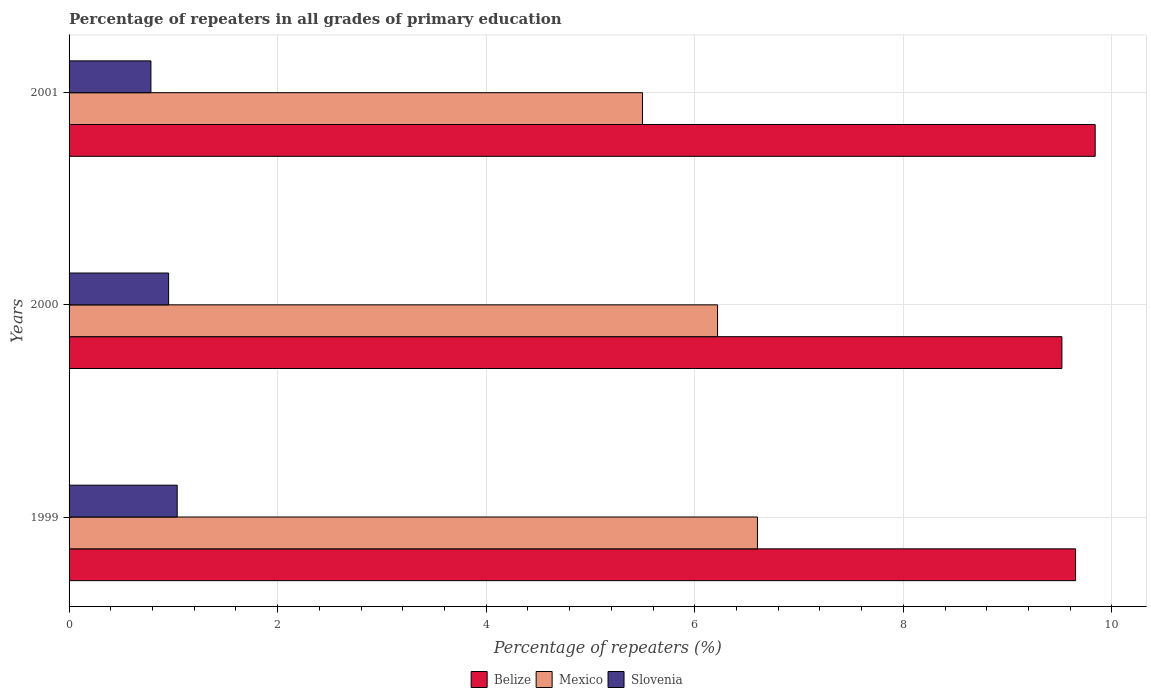How many groups of bars are there?
Give a very brief answer. 3. What is the percentage of repeaters in Mexico in 2000?
Offer a terse response. 6.22. Across all years, what is the maximum percentage of repeaters in Mexico?
Provide a succinct answer. 6.6. Across all years, what is the minimum percentage of repeaters in Belize?
Give a very brief answer. 9.52. In which year was the percentage of repeaters in Slovenia maximum?
Provide a short and direct response. 1999. In which year was the percentage of repeaters in Belize minimum?
Keep it short and to the point. 2000. What is the total percentage of repeaters in Belize in the graph?
Make the answer very short. 29.01. What is the difference between the percentage of repeaters in Mexico in 2000 and that in 2001?
Your answer should be compact. 0.72. What is the difference between the percentage of repeaters in Belize in 2000 and the percentage of repeaters in Mexico in 2001?
Offer a terse response. 4.02. What is the average percentage of repeaters in Slovenia per year?
Ensure brevity in your answer.  0.93. In the year 1999, what is the difference between the percentage of repeaters in Belize and percentage of repeaters in Mexico?
Give a very brief answer. 3.05. In how many years, is the percentage of repeaters in Slovenia greater than 6 %?
Give a very brief answer. 0. What is the ratio of the percentage of repeaters in Belize in 2000 to that in 2001?
Ensure brevity in your answer.  0.97. What is the difference between the highest and the second highest percentage of repeaters in Slovenia?
Ensure brevity in your answer.  0.08. What is the difference between the highest and the lowest percentage of repeaters in Mexico?
Make the answer very short. 1.1. Is the sum of the percentage of repeaters in Slovenia in 2000 and 2001 greater than the maximum percentage of repeaters in Belize across all years?
Keep it short and to the point. No. What does the 1st bar from the top in 2000 represents?
Provide a succinct answer. Slovenia. What does the 2nd bar from the bottom in 1999 represents?
Your response must be concise. Mexico. How many years are there in the graph?
Provide a succinct answer. 3. What is the difference between two consecutive major ticks on the X-axis?
Make the answer very short. 2. Are the values on the major ticks of X-axis written in scientific E-notation?
Provide a short and direct response. No. Does the graph contain grids?
Make the answer very short. Yes. How are the legend labels stacked?
Your response must be concise. Horizontal. What is the title of the graph?
Your answer should be very brief. Percentage of repeaters in all grades of primary education. Does "Ireland" appear as one of the legend labels in the graph?
Your response must be concise. No. What is the label or title of the X-axis?
Your answer should be very brief. Percentage of repeaters (%). What is the label or title of the Y-axis?
Offer a very short reply. Years. What is the Percentage of repeaters (%) of Belize in 1999?
Offer a very short reply. 9.65. What is the Percentage of repeaters (%) in Mexico in 1999?
Provide a short and direct response. 6.6. What is the Percentage of repeaters (%) of Slovenia in 1999?
Your answer should be compact. 1.04. What is the Percentage of repeaters (%) of Belize in 2000?
Make the answer very short. 9.52. What is the Percentage of repeaters (%) of Mexico in 2000?
Offer a very short reply. 6.22. What is the Percentage of repeaters (%) of Slovenia in 2000?
Provide a short and direct response. 0.95. What is the Percentage of repeaters (%) of Belize in 2001?
Give a very brief answer. 9.84. What is the Percentage of repeaters (%) of Mexico in 2001?
Make the answer very short. 5.5. What is the Percentage of repeaters (%) of Slovenia in 2001?
Give a very brief answer. 0.78. Across all years, what is the maximum Percentage of repeaters (%) in Belize?
Keep it short and to the point. 9.84. Across all years, what is the maximum Percentage of repeaters (%) in Mexico?
Your response must be concise. 6.6. Across all years, what is the maximum Percentage of repeaters (%) in Slovenia?
Give a very brief answer. 1.04. Across all years, what is the minimum Percentage of repeaters (%) in Belize?
Offer a very short reply. 9.52. Across all years, what is the minimum Percentage of repeaters (%) of Mexico?
Keep it short and to the point. 5.5. Across all years, what is the minimum Percentage of repeaters (%) in Slovenia?
Ensure brevity in your answer.  0.78. What is the total Percentage of repeaters (%) in Belize in the graph?
Offer a terse response. 29.01. What is the total Percentage of repeaters (%) of Mexico in the graph?
Your answer should be compact. 18.32. What is the total Percentage of repeaters (%) in Slovenia in the graph?
Your answer should be very brief. 2.78. What is the difference between the Percentage of repeaters (%) of Belize in 1999 and that in 2000?
Provide a short and direct response. 0.13. What is the difference between the Percentage of repeaters (%) in Mexico in 1999 and that in 2000?
Offer a very short reply. 0.38. What is the difference between the Percentage of repeaters (%) in Slovenia in 1999 and that in 2000?
Offer a terse response. 0.08. What is the difference between the Percentage of repeaters (%) of Belize in 1999 and that in 2001?
Keep it short and to the point. -0.19. What is the difference between the Percentage of repeaters (%) in Mexico in 1999 and that in 2001?
Offer a very short reply. 1.1. What is the difference between the Percentage of repeaters (%) in Slovenia in 1999 and that in 2001?
Give a very brief answer. 0.25. What is the difference between the Percentage of repeaters (%) in Belize in 2000 and that in 2001?
Your response must be concise. -0.32. What is the difference between the Percentage of repeaters (%) of Mexico in 2000 and that in 2001?
Offer a very short reply. 0.72. What is the difference between the Percentage of repeaters (%) of Slovenia in 2000 and that in 2001?
Your answer should be compact. 0.17. What is the difference between the Percentage of repeaters (%) of Belize in 1999 and the Percentage of repeaters (%) of Mexico in 2000?
Keep it short and to the point. 3.43. What is the difference between the Percentage of repeaters (%) of Belize in 1999 and the Percentage of repeaters (%) of Slovenia in 2000?
Provide a succinct answer. 8.7. What is the difference between the Percentage of repeaters (%) in Mexico in 1999 and the Percentage of repeaters (%) in Slovenia in 2000?
Provide a succinct answer. 5.65. What is the difference between the Percentage of repeaters (%) of Belize in 1999 and the Percentage of repeaters (%) of Mexico in 2001?
Make the answer very short. 4.15. What is the difference between the Percentage of repeaters (%) in Belize in 1999 and the Percentage of repeaters (%) in Slovenia in 2001?
Provide a succinct answer. 8.87. What is the difference between the Percentage of repeaters (%) of Mexico in 1999 and the Percentage of repeaters (%) of Slovenia in 2001?
Your answer should be compact. 5.82. What is the difference between the Percentage of repeaters (%) of Belize in 2000 and the Percentage of repeaters (%) of Mexico in 2001?
Your answer should be compact. 4.02. What is the difference between the Percentage of repeaters (%) in Belize in 2000 and the Percentage of repeaters (%) in Slovenia in 2001?
Offer a very short reply. 8.74. What is the difference between the Percentage of repeaters (%) in Mexico in 2000 and the Percentage of repeaters (%) in Slovenia in 2001?
Keep it short and to the point. 5.43. What is the average Percentage of repeaters (%) of Belize per year?
Provide a succinct answer. 9.67. What is the average Percentage of repeaters (%) of Mexico per year?
Ensure brevity in your answer.  6.11. What is the average Percentage of repeaters (%) in Slovenia per year?
Offer a very short reply. 0.93. In the year 1999, what is the difference between the Percentage of repeaters (%) in Belize and Percentage of repeaters (%) in Mexico?
Give a very brief answer. 3.05. In the year 1999, what is the difference between the Percentage of repeaters (%) in Belize and Percentage of repeaters (%) in Slovenia?
Provide a short and direct response. 8.61. In the year 1999, what is the difference between the Percentage of repeaters (%) of Mexico and Percentage of repeaters (%) of Slovenia?
Offer a terse response. 5.56. In the year 2000, what is the difference between the Percentage of repeaters (%) in Belize and Percentage of repeaters (%) in Mexico?
Offer a terse response. 3.3. In the year 2000, what is the difference between the Percentage of repeaters (%) in Belize and Percentage of repeaters (%) in Slovenia?
Provide a short and direct response. 8.57. In the year 2000, what is the difference between the Percentage of repeaters (%) in Mexico and Percentage of repeaters (%) in Slovenia?
Offer a very short reply. 5.26. In the year 2001, what is the difference between the Percentage of repeaters (%) of Belize and Percentage of repeaters (%) of Mexico?
Provide a succinct answer. 4.34. In the year 2001, what is the difference between the Percentage of repeaters (%) in Belize and Percentage of repeaters (%) in Slovenia?
Ensure brevity in your answer.  9.05. In the year 2001, what is the difference between the Percentage of repeaters (%) in Mexico and Percentage of repeaters (%) in Slovenia?
Provide a succinct answer. 4.71. What is the ratio of the Percentage of repeaters (%) in Belize in 1999 to that in 2000?
Give a very brief answer. 1.01. What is the ratio of the Percentage of repeaters (%) in Mexico in 1999 to that in 2000?
Your answer should be compact. 1.06. What is the ratio of the Percentage of repeaters (%) in Slovenia in 1999 to that in 2000?
Keep it short and to the point. 1.09. What is the ratio of the Percentage of repeaters (%) in Belize in 1999 to that in 2001?
Give a very brief answer. 0.98. What is the ratio of the Percentage of repeaters (%) of Mexico in 1999 to that in 2001?
Offer a very short reply. 1.2. What is the ratio of the Percentage of repeaters (%) of Slovenia in 1999 to that in 2001?
Your response must be concise. 1.32. What is the ratio of the Percentage of repeaters (%) in Belize in 2000 to that in 2001?
Make the answer very short. 0.97. What is the ratio of the Percentage of repeaters (%) of Mexico in 2000 to that in 2001?
Your answer should be compact. 1.13. What is the ratio of the Percentage of repeaters (%) of Slovenia in 2000 to that in 2001?
Give a very brief answer. 1.22. What is the difference between the highest and the second highest Percentage of repeaters (%) of Belize?
Keep it short and to the point. 0.19. What is the difference between the highest and the second highest Percentage of repeaters (%) of Mexico?
Ensure brevity in your answer.  0.38. What is the difference between the highest and the second highest Percentage of repeaters (%) of Slovenia?
Keep it short and to the point. 0.08. What is the difference between the highest and the lowest Percentage of repeaters (%) in Belize?
Your response must be concise. 0.32. What is the difference between the highest and the lowest Percentage of repeaters (%) of Mexico?
Keep it short and to the point. 1.1. What is the difference between the highest and the lowest Percentage of repeaters (%) of Slovenia?
Make the answer very short. 0.25. 